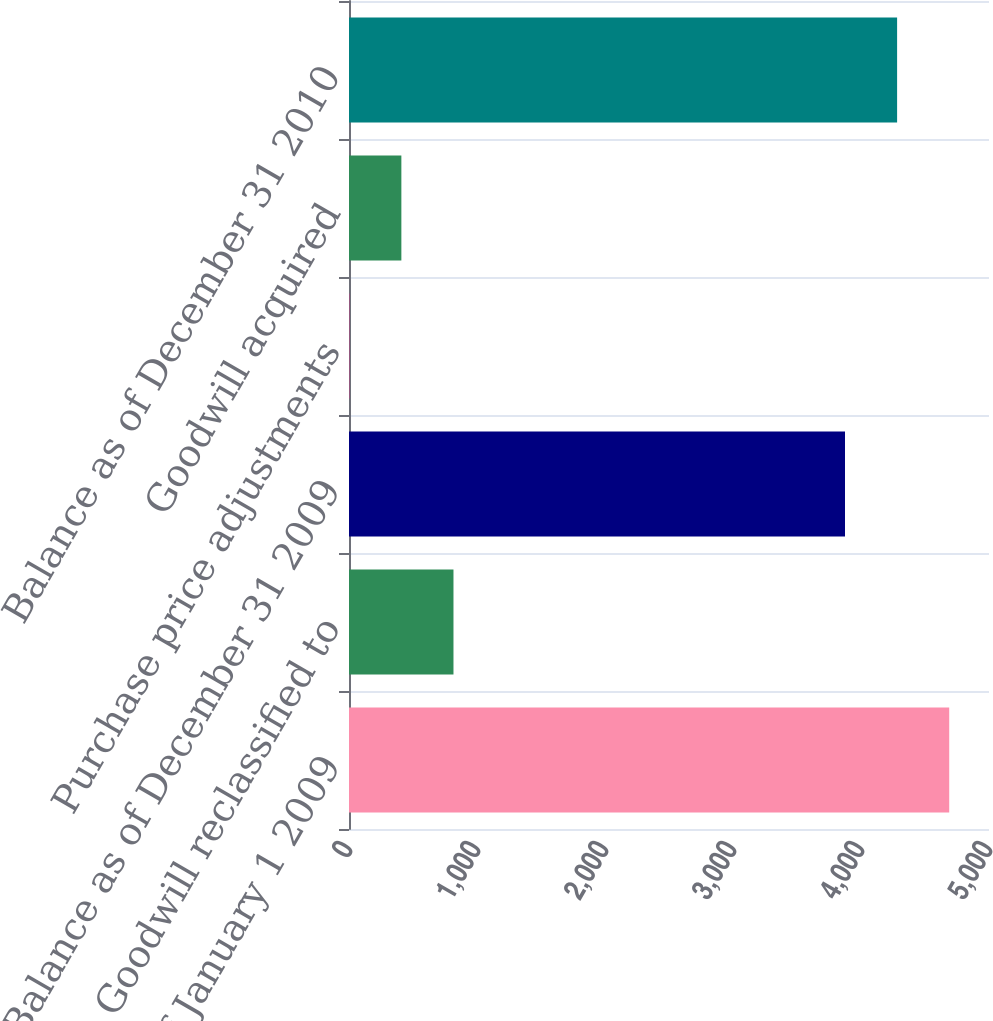Convert chart to OTSL. <chart><loc_0><loc_0><loc_500><loc_500><bar_chart><fcel>Balance as of January 1 2009<fcel>Goodwill reclassified to<fcel>Balance as of December 31 2009<fcel>Purchase price adjustments<fcel>Goodwill acquired<fcel>Balance as of December 31 2010<nl><fcel>4689.2<fcel>816.2<fcel>3875<fcel>2<fcel>409.1<fcel>4282.1<nl></chart> 